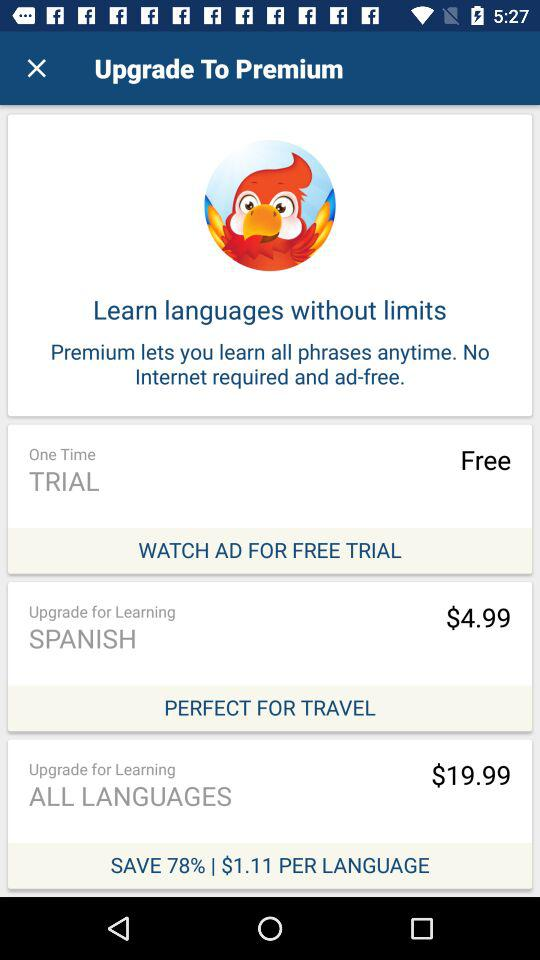Which language course is perfect for travel? The language course that is perfect for travel is "SPANISH". 